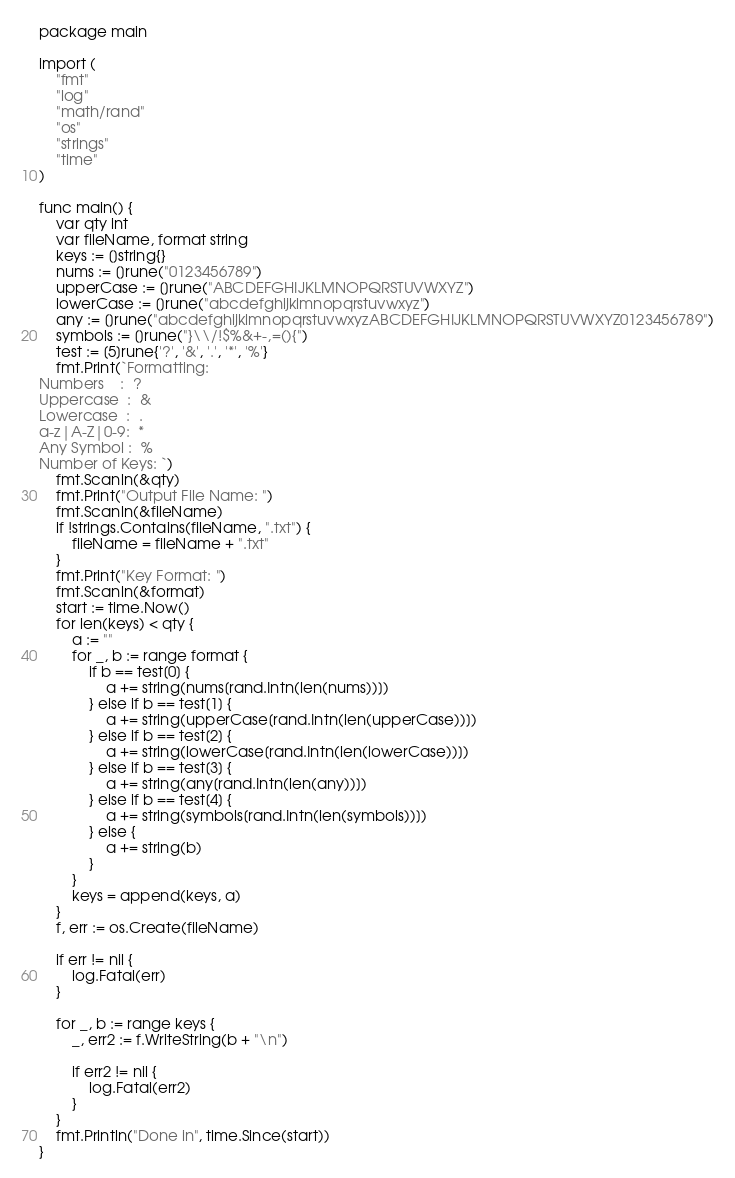Convert code to text. <code><loc_0><loc_0><loc_500><loc_500><_Go_>package main

import (
	"fmt"
	"log"
	"math/rand"
	"os"
	"strings"
	"time"
)

func main() {
	var qty int
	var fileName, format string
	keys := []string{}
	nums := []rune("0123456789")
	upperCase := []rune("ABCDEFGHIJKLMNOPQRSTUVWXYZ")
	lowerCase := []rune("abcdefghijklmnopqrstuvwxyz")
	any := []rune("abcdefghijklmnopqrstuvwxyzABCDEFGHIJKLMNOPQRSTUVWXYZ0123456789")
	symbols := []rune("}\\/!$%&+-,=(){")
	test := [5]rune{'?', '&', '.', '*', '%'}
	fmt.Print(`Formatting:
Numbers    :  ?
Uppercase  :  &
Lowercase  :  .
a-z|A-Z|0-9:  *
Any Symbol :  %
Number of Keys: `)
	fmt.Scanln(&qty)
	fmt.Print("Output File Name: ")
	fmt.Scanln(&fileName)
	if !strings.Contains(fileName, ".txt") {
		fileName = fileName + ".txt"
	}
	fmt.Print("Key Format: ")
	fmt.Scanln(&format)
	start := time.Now()
	for len(keys) < qty {
		a := ""
		for _, b := range format {
			if b == test[0] {
				a += string(nums[rand.Intn(len(nums))])
			} else if b == test[1] {
				a += string(upperCase[rand.Intn(len(upperCase))])
			} else if b == test[2] {
				a += string(lowerCase[rand.Intn(len(lowerCase))])
			} else if b == test[3] {
				a += string(any[rand.Intn(len(any))])
			} else if b == test[4] {
				a += string(symbols[rand.Intn(len(symbols))])
			} else {
				a += string(b)
			}
		}
		keys = append(keys, a)
	}
	f, err := os.Create(fileName)

	if err != nil {
		log.Fatal(err)
	}

	for _, b := range keys {
		_, err2 := f.WriteString(b + "\n")

		if err2 != nil {
			log.Fatal(err2)
		}
	}
	fmt.Println("Done in", time.Since(start))
}
</code> 